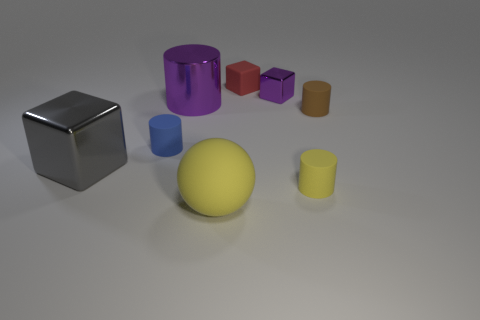The rubber thing that is behind the matte cylinder that is on the right side of the yellow cylinder is what shape?
Your answer should be very brief. Cube. There is a small matte thing that is both in front of the brown rubber cylinder and to the left of the yellow matte cylinder; what is its shape?
Provide a short and direct response. Cylinder. What number of objects are large red spheres or brown things that are to the right of the tiny red block?
Offer a terse response. 1. What material is the large thing that is the same shape as the small blue rubber thing?
Provide a short and direct response. Metal. Is there anything else that has the same material as the large gray object?
Give a very brief answer. Yes. There is a big thing that is behind the yellow cylinder and right of the large shiny block; what is its material?
Your answer should be very brief. Metal. How many big yellow objects have the same shape as the large purple thing?
Offer a terse response. 0. There is a cylinder that is on the right side of the tiny cylinder in front of the small blue thing; what is its color?
Keep it short and to the point. Brown. Are there the same number of large gray things in front of the big yellow rubber object and tiny cyan blocks?
Offer a terse response. Yes. Are there any purple shiny cubes of the same size as the red object?
Provide a short and direct response. Yes. 